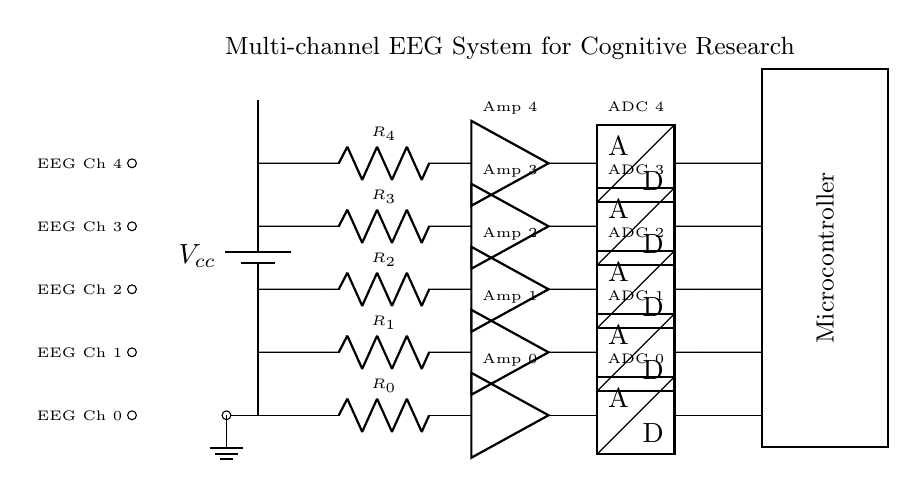What is the power supply voltage in this circuit? The circuit shows a power supply labeled as Vcc, which indicates it is providing the necessary voltage for operation. The specific value isn't given here, but it is denoted as Vcc.
Answer: Vcc How many channels does this EEG system have? The diagram clearly shows five separate channels drawn in parallel, each receiving input and processing signals. This is evident from the iterations in the circuit that are labeled for each channel.
Answer: Five What type of components are used to process the EEG signals? The circuit diagram includes resistors, amplifiers, and ADCs for each channel. Each channel contains one resistor, one amplifier, and one analog-to-digital converter, which are critical for processing EEG signals.
Answer: Resistor, amplifier, ADC What is the function of the microcontroller in this circuit? The microcontroller is depicted as a block that processes the signals from the ADCs after the amplification stage. It is vital for controlling the system and processing data from the EEG channels.
Answer: Data processing What might be the advantage of using a parallel circuit configuration for this EEG system? A parallel circuit allows all channels to receive the same voltage from the power supply, ensuring equal signal conditions across all channels. Additionally, if one channel fails, the others remain functional, increasing reliability.
Answer: Increased reliability 